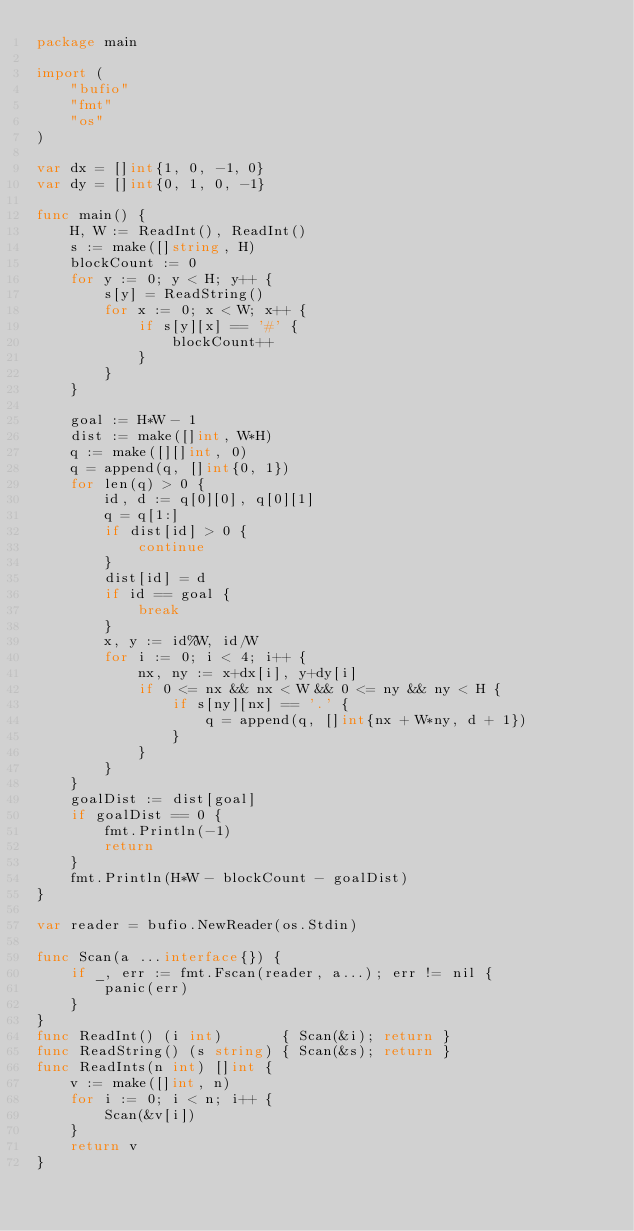<code> <loc_0><loc_0><loc_500><loc_500><_Go_>package main

import (
	"bufio"
	"fmt"
	"os"
)

var dx = []int{1, 0, -1, 0}
var dy = []int{0, 1, 0, -1}

func main() {
	H, W := ReadInt(), ReadInt()
	s := make([]string, H)
	blockCount := 0
	for y := 0; y < H; y++ {
		s[y] = ReadString()
		for x := 0; x < W; x++ {
			if s[y][x] == '#' {
				blockCount++
			}
		}
	}

	goal := H*W - 1
	dist := make([]int, W*H)
	q := make([][]int, 0)
	q = append(q, []int{0, 1})
	for len(q) > 0 {
		id, d := q[0][0], q[0][1]
		q = q[1:]
		if dist[id] > 0 {
			continue
		}
		dist[id] = d
		if id == goal {
			break
		}
		x, y := id%W, id/W
		for i := 0; i < 4; i++ {
			nx, ny := x+dx[i], y+dy[i]
			if 0 <= nx && nx < W && 0 <= ny && ny < H {
				if s[ny][nx] == '.' {
					q = append(q, []int{nx + W*ny, d + 1})
				}
			}
		}
	}
	goalDist := dist[goal]
	if goalDist == 0 {
		fmt.Println(-1)
		return
	}
	fmt.Println(H*W - blockCount - goalDist)
}

var reader = bufio.NewReader(os.Stdin)

func Scan(a ...interface{}) {
	if _, err := fmt.Fscan(reader, a...); err != nil {
		panic(err)
	}
}
func ReadInt() (i int)       { Scan(&i); return }
func ReadString() (s string) { Scan(&s); return }
func ReadInts(n int) []int {
	v := make([]int, n)
	for i := 0; i < n; i++ {
		Scan(&v[i])
	}
	return v
}
</code> 